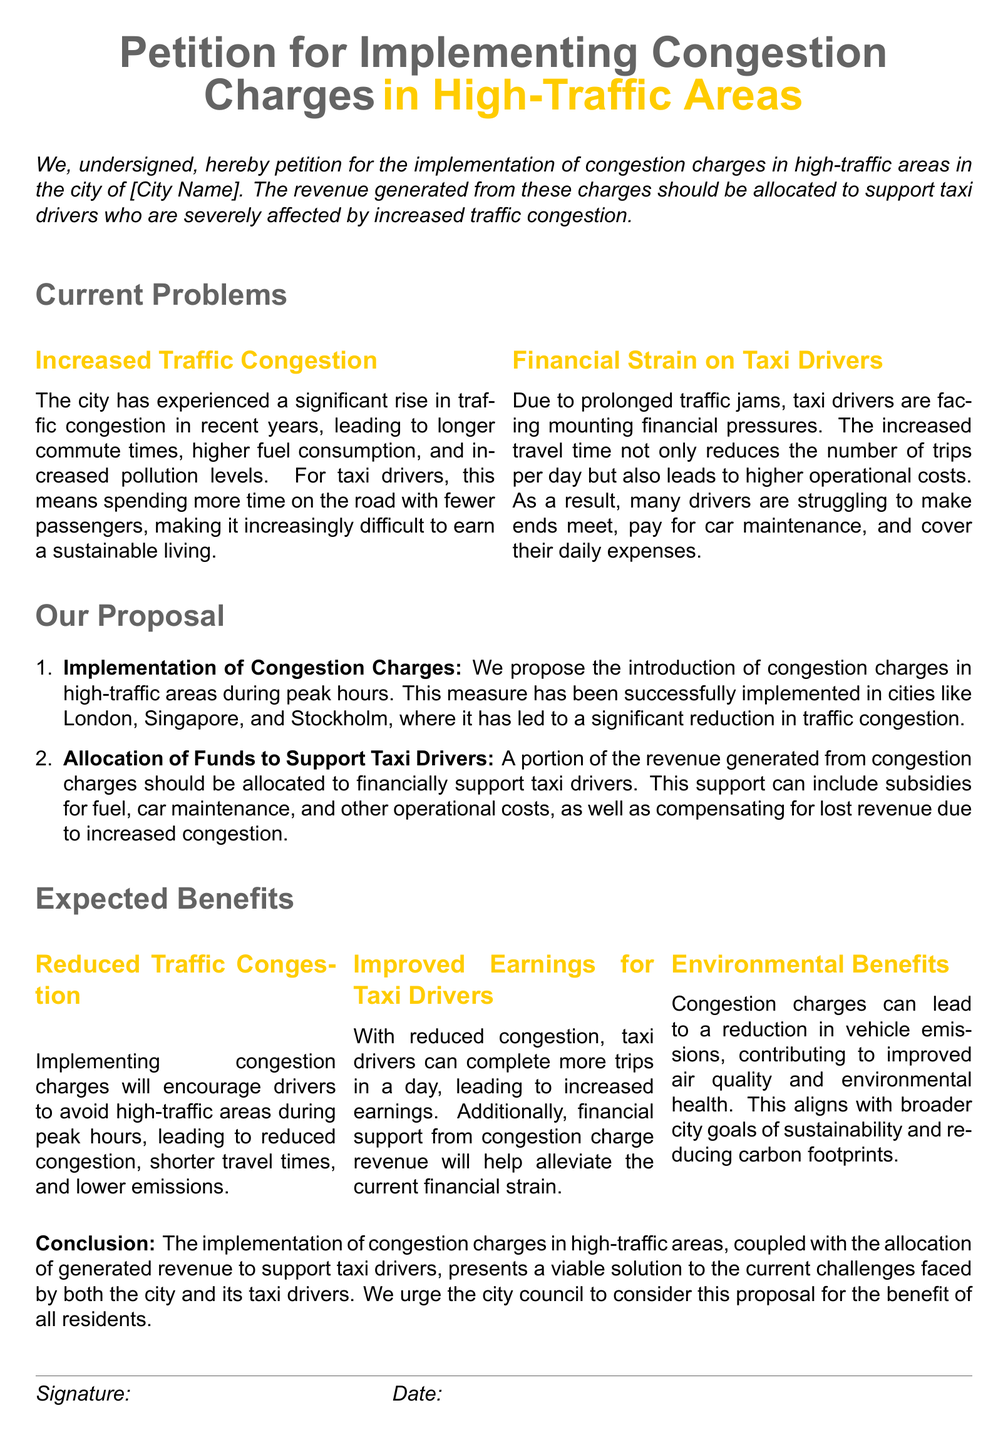what is the title of the petition? The title is presented at the top of the document, indicating the subject of the petition.
Answer: Petition for Implementing Congestion Charges in High-Traffic Areas what is one major problem caused by increased traffic congestion? The document states a specific problem regarding taxi drivers' earnings due to increased congestion.
Answer: Longer commute times how should the revenue from congestion charges be used? The petition outlines a specific allocation for the revenue generated from congestion charges.
Answer: To support taxi drivers name one city where congestion charges have been successfully implemented. The document provides examples of cities that have implemented congestion charges effectively.
Answer: London what is one expected benefit of implementation? The petition lists expected benefits that arise from implementing congestion charges in high-traffic areas.
Answer: Reduced Traffic Congestion how will taxi drivers benefit from reduced congestion? The document explains how reducing traffic congestion will impact taxi drivers' abilities financially.
Answer: Increased earnings what does the proposal start with? The document outlines a specific first action within the proposal for addressing the congestion issue.
Answer: Implementation of Congestion Charges what is one additional support proposed for taxi drivers? The document details another way to assist taxi drivers facing financial challenges.
Answer: Subsidies for fuel 